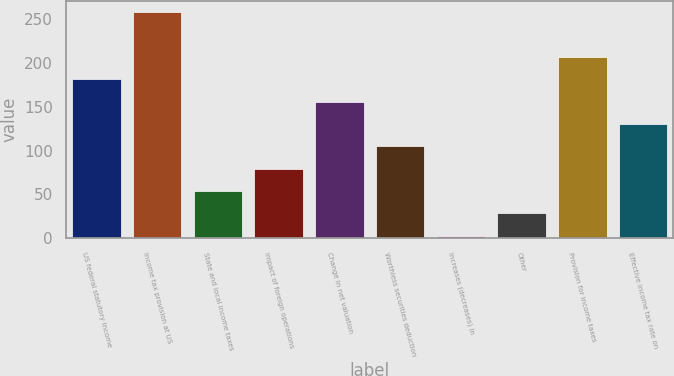Convert chart. <chart><loc_0><loc_0><loc_500><loc_500><bar_chart><fcel>US federal statutory income<fcel>Income tax provision at US<fcel>State and local income taxes<fcel>Impact of foreign operations<fcel>Change in net valuation<fcel>Worthless securities deduction<fcel>Increases (decreases) in<fcel>Other<fcel>Provision for income taxes<fcel>Effective income tax rate on<nl><fcel>181.69<fcel>258.4<fcel>53.84<fcel>79.41<fcel>156.12<fcel>104.98<fcel>2.7<fcel>28.27<fcel>207.26<fcel>130.55<nl></chart> 